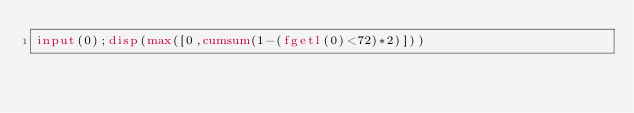Convert code to text. <code><loc_0><loc_0><loc_500><loc_500><_Octave_>input(0);disp(max([0,cumsum(1-(fgetl(0)<72)*2)]))</code> 